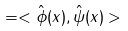<formula> <loc_0><loc_0><loc_500><loc_500>= < \hat { \phi } ( x ) , \hat { \psi } ( x ) ></formula> 